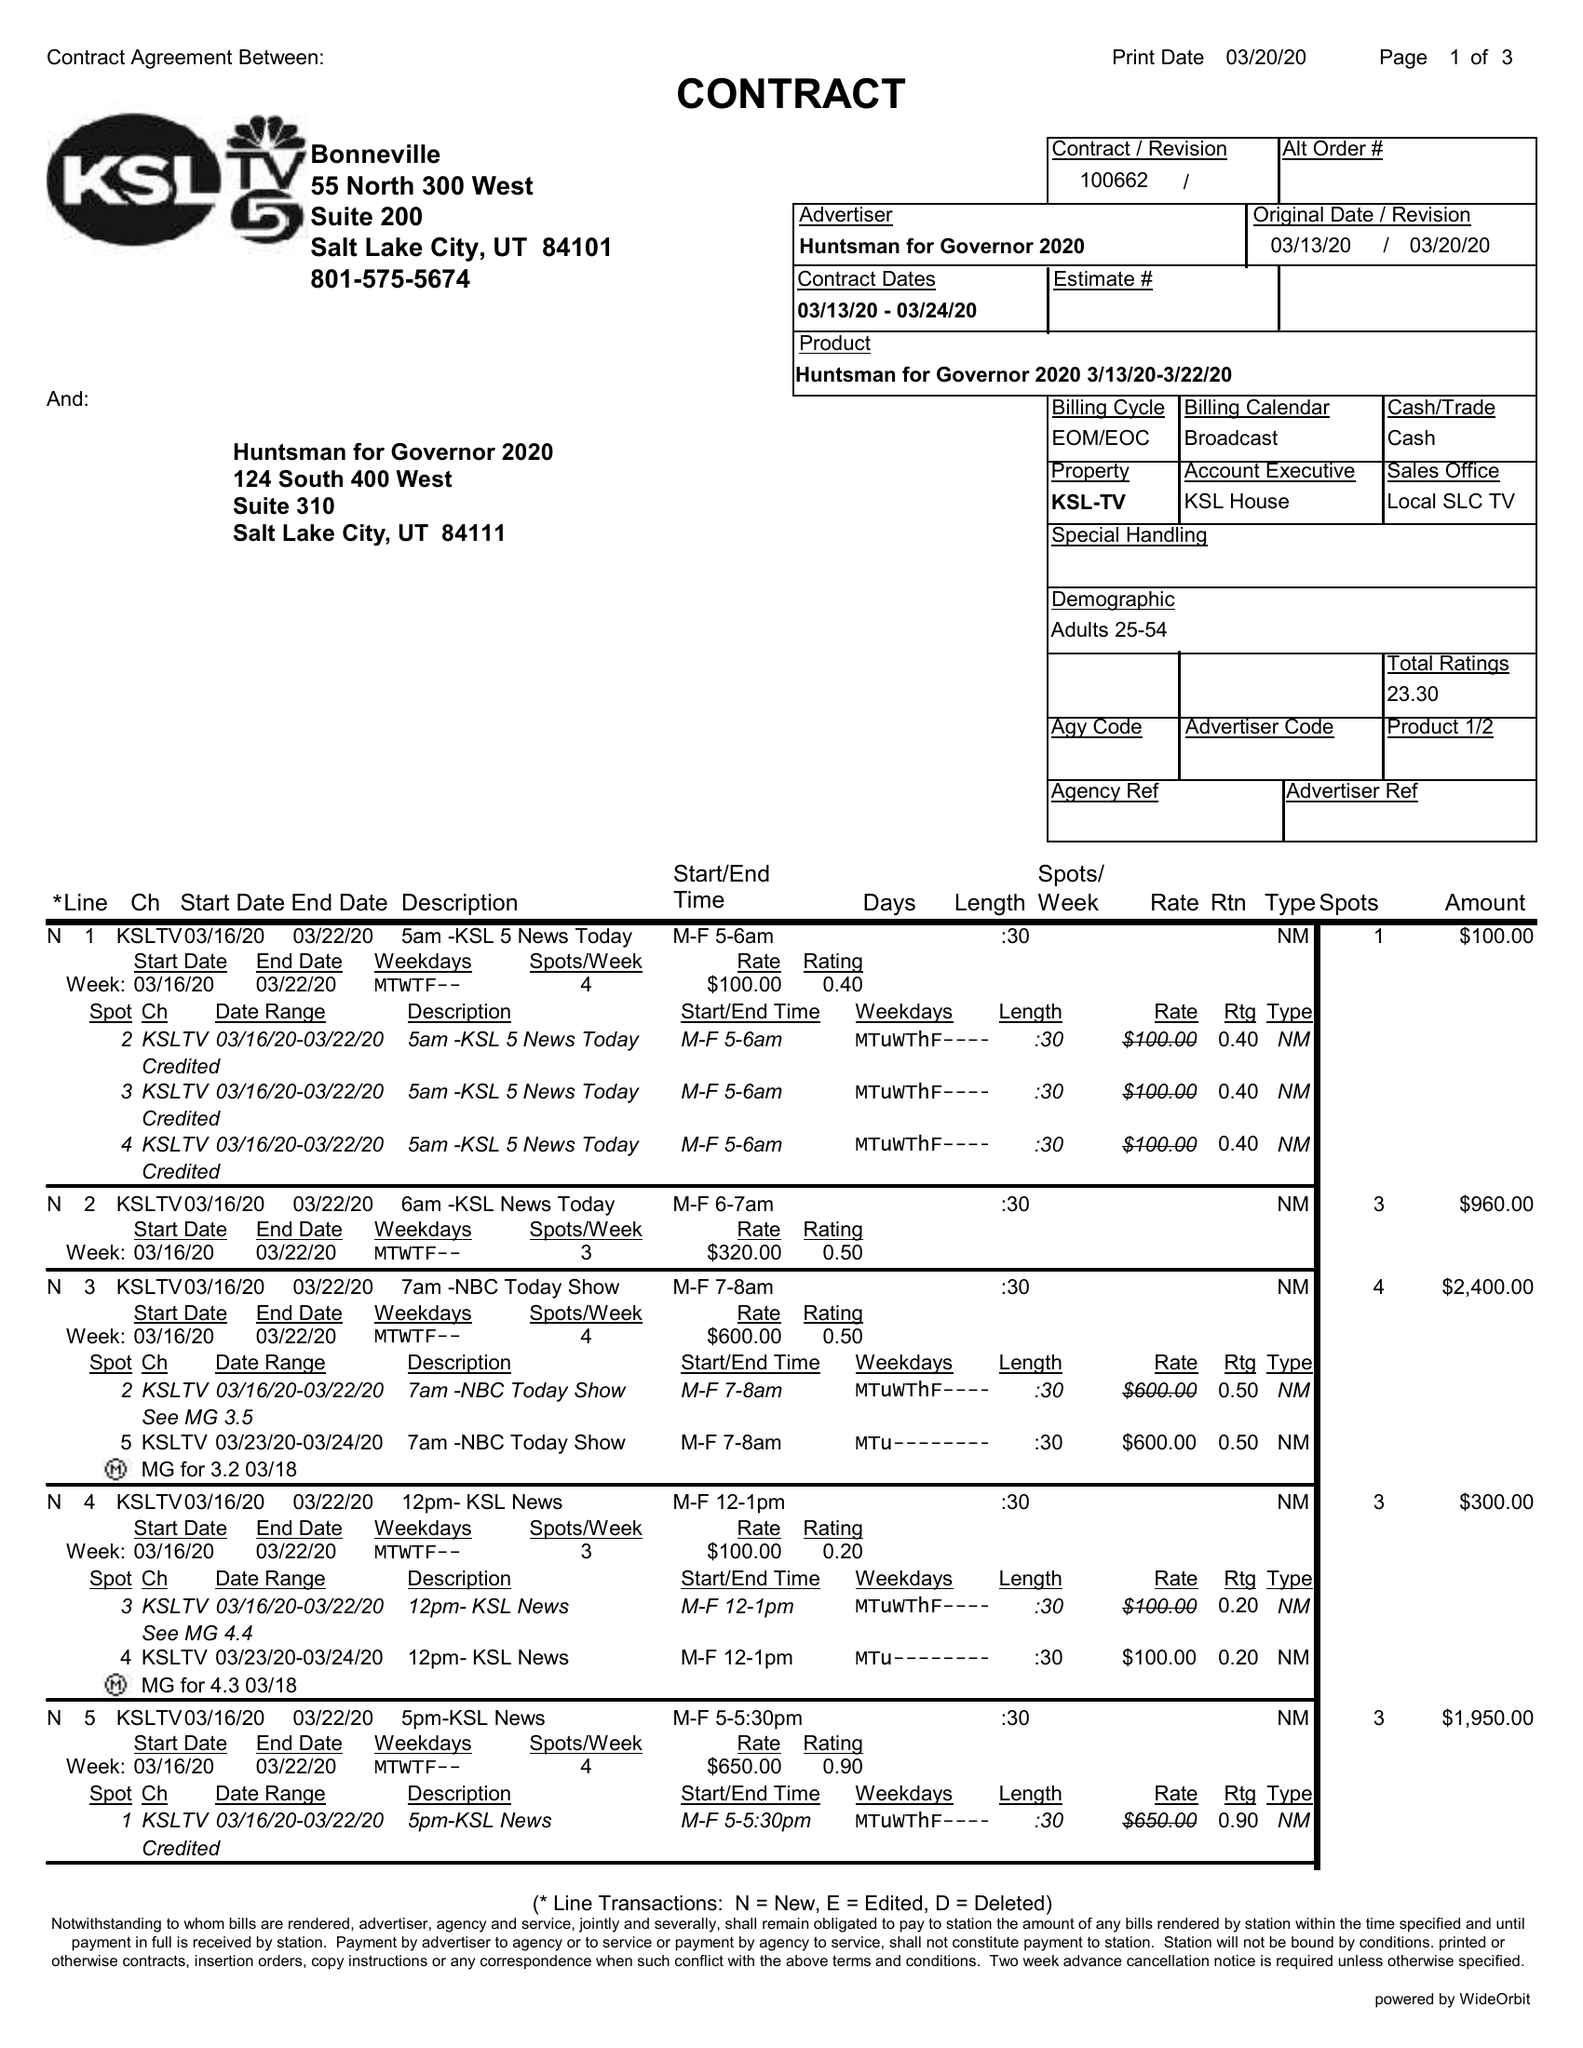What is the value for the flight_from?
Answer the question using a single word or phrase. 03/13/20 